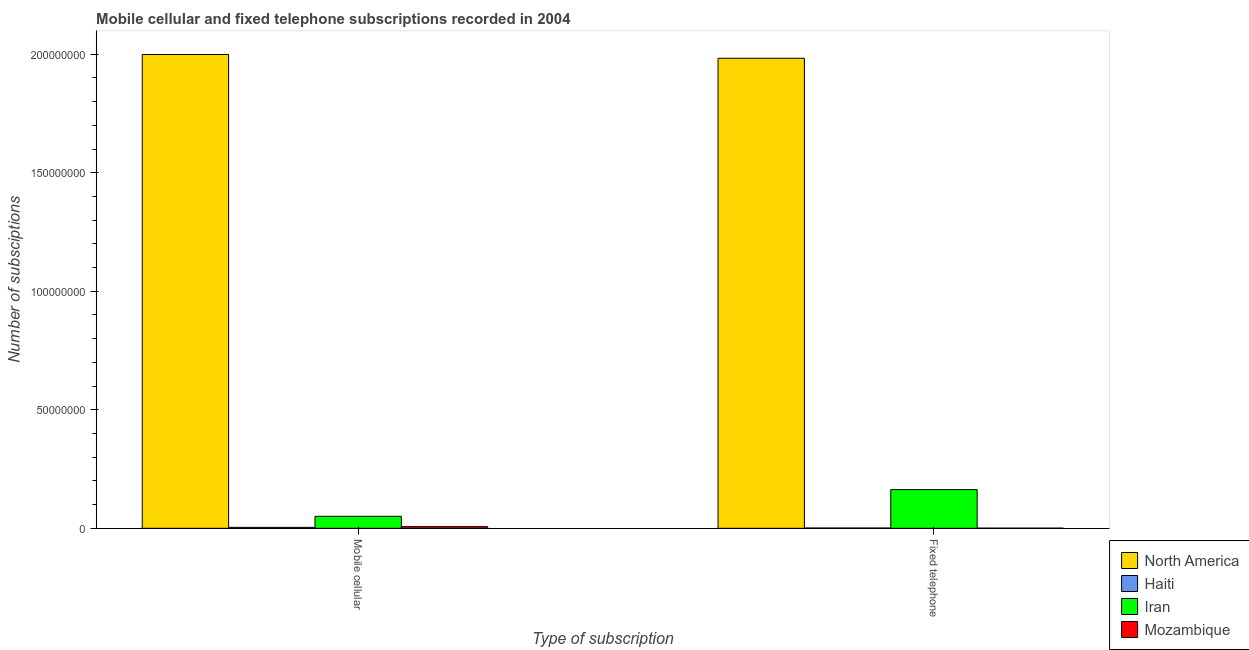Are the number of bars per tick equal to the number of legend labels?
Keep it short and to the point. Yes. Are the number of bars on each tick of the X-axis equal?
Your answer should be very brief. Yes. How many bars are there on the 2nd tick from the left?
Give a very brief answer. 4. How many bars are there on the 1st tick from the right?
Make the answer very short. 4. What is the label of the 2nd group of bars from the left?
Offer a very short reply. Fixed telephone. What is the number of mobile cellular subscriptions in North America?
Offer a terse response. 2.00e+08. Across all countries, what is the maximum number of fixed telephone subscriptions?
Your answer should be very brief. 1.98e+08. Across all countries, what is the minimum number of mobile cellular subscriptions?
Offer a terse response. 4.00e+05. In which country was the number of fixed telephone subscriptions maximum?
Provide a short and direct response. North America. In which country was the number of fixed telephone subscriptions minimum?
Offer a very short reply. Mozambique. What is the total number of fixed telephone subscriptions in the graph?
Ensure brevity in your answer.  2.15e+08. What is the difference between the number of mobile cellular subscriptions in Mozambique and that in Haiti?
Your answer should be very brief. 3.08e+05. What is the difference between the number of fixed telephone subscriptions in Iran and the number of mobile cellular subscriptions in Mozambique?
Give a very brief answer. 1.56e+07. What is the average number of fixed telephone subscriptions per country?
Provide a short and direct response. 5.37e+07. What is the difference between the number of fixed telephone subscriptions and number of mobile cellular subscriptions in North America?
Keep it short and to the point. -1.58e+06. In how many countries, is the number of fixed telephone subscriptions greater than 140000000 ?
Provide a succinct answer. 1. What is the ratio of the number of mobile cellular subscriptions in North America to that in Haiti?
Provide a succinct answer. 499.72. Is the number of mobile cellular subscriptions in North America less than that in Iran?
Offer a terse response. No. In how many countries, is the number of mobile cellular subscriptions greater than the average number of mobile cellular subscriptions taken over all countries?
Your response must be concise. 1. What does the 2nd bar from the left in Mobile cellular represents?
Provide a short and direct response. Haiti. What does the 1st bar from the right in Fixed telephone represents?
Your answer should be compact. Mozambique. Does the graph contain any zero values?
Provide a succinct answer. No. Where does the legend appear in the graph?
Your answer should be compact. Bottom right. What is the title of the graph?
Provide a short and direct response. Mobile cellular and fixed telephone subscriptions recorded in 2004. What is the label or title of the X-axis?
Your answer should be compact. Type of subscription. What is the label or title of the Y-axis?
Your answer should be very brief. Number of subsciptions. What is the Number of subsciptions in North America in Mobile cellular?
Give a very brief answer. 2.00e+08. What is the Number of subsciptions of Haiti in Mobile cellular?
Provide a short and direct response. 4.00e+05. What is the Number of subsciptions of Iran in Mobile cellular?
Keep it short and to the point. 5.08e+06. What is the Number of subsciptions of Mozambique in Mobile cellular?
Offer a terse response. 7.08e+05. What is the Number of subsciptions of North America in Fixed telephone?
Make the answer very short. 1.98e+08. What is the Number of subsciptions of Iran in Fixed telephone?
Your answer should be very brief. 1.63e+07. What is the Number of subsciptions in Mozambique in Fixed telephone?
Ensure brevity in your answer.  7.53e+04. Across all Type of subscription, what is the maximum Number of subsciptions in North America?
Provide a succinct answer. 2.00e+08. Across all Type of subscription, what is the maximum Number of subsciptions in Haiti?
Make the answer very short. 4.00e+05. Across all Type of subscription, what is the maximum Number of subsciptions in Iran?
Your answer should be very brief. 1.63e+07. Across all Type of subscription, what is the maximum Number of subsciptions in Mozambique?
Offer a terse response. 7.08e+05. Across all Type of subscription, what is the minimum Number of subsciptions of North America?
Your response must be concise. 1.98e+08. Across all Type of subscription, what is the minimum Number of subsciptions of Haiti?
Provide a short and direct response. 1.40e+05. Across all Type of subscription, what is the minimum Number of subsciptions in Iran?
Ensure brevity in your answer.  5.08e+06. Across all Type of subscription, what is the minimum Number of subsciptions in Mozambique?
Your answer should be very brief. 7.53e+04. What is the total Number of subsciptions of North America in the graph?
Give a very brief answer. 3.98e+08. What is the total Number of subsciptions of Haiti in the graph?
Provide a succinct answer. 5.40e+05. What is the total Number of subsciptions in Iran in the graph?
Offer a terse response. 2.14e+07. What is the total Number of subsciptions in Mozambique in the graph?
Ensure brevity in your answer.  7.83e+05. What is the difference between the Number of subsciptions of North America in Mobile cellular and that in Fixed telephone?
Provide a succinct answer. 1.58e+06. What is the difference between the Number of subsciptions in Haiti in Mobile cellular and that in Fixed telephone?
Provide a short and direct response. 2.60e+05. What is the difference between the Number of subsciptions in Iran in Mobile cellular and that in Fixed telephone?
Your answer should be compact. -1.13e+07. What is the difference between the Number of subsciptions in Mozambique in Mobile cellular and that in Fixed telephone?
Offer a very short reply. 6.33e+05. What is the difference between the Number of subsciptions in North America in Mobile cellular and the Number of subsciptions in Haiti in Fixed telephone?
Offer a very short reply. 2.00e+08. What is the difference between the Number of subsciptions in North America in Mobile cellular and the Number of subsciptions in Iran in Fixed telephone?
Your answer should be very brief. 1.84e+08. What is the difference between the Number of subsciptions in North America in Mobile cellular and the Number of subsciptions in Mozambique in Fixed telephone?
Make the answer very short. 2.00e+08. What is the difference between the Number of subsciptions in Haiti in Mobile cellular and the Number of subsciptions in Iran in Fixed telephone?
Ensure brevity in your answer.  -1.59e+07. What is the difference between the Number of subsciptions of Haiti in Mobile cellular and the Number of subsciptions of Mozambique in Fixed telephone?
Provide a short and direct response. 3.25e+05. What is the difference between the Number of subsciptions of Iran in Mobile cellular and the Number of subsciptions of Mozambique in Fixed telephone?
Offer a very short reply. 5.00e+06. What is the average Number of subsciptions of North America per Type of subscription?
Your answer should be very brief. 1.99e+08. What is the average Number of subsciptions in Iran per Type of subscription?
Keep it short and to the point. 1.07e+07. What is the average Number of subsciptions of Mozambique per Type of subscription?
Offer a terse response. 3.92e+05. What is the difference between the Number of subsciptions of North America and Number of subsciptions of Haiti in Mobile cellular?
Your response must be concise. 1.99e+08. What is the difference between the Number of subsciptions in North America and Number of subsciptions in Iran in Mobile cellular?
Provide a short and direct response. 1.95e+08. What is the difference between the Number of subsciptions of North America and Number of subsciptions of Mozambique in Mobile cellular?
Give a very brief answer. 1.99e+08. What is the difference between the Number of subsciptions in Haiti and Number of subsciptions in Iran in Mobile cellular?
Your response must be concise. -4.68e+06. What is the difference between the Number of subsciptions of Haiti and Number of subsciptions of Mozambique in Mobile cellular?
Keep it short and to the point. -3.08e+05. What is the difference between the Number of subsciptions in Iran and Number of subsciptions in Mozambique in Mobile cellular?
Offer a very short reply. 4.37e+06. What is the difference between the Number of subsciptions of North America and Number of subsciptions of Haiti in Fixed telephone?
Your answer should be compact. 1.98e+08. What is the difference between the Number of subsciptions in North America and Number of subsciptions in Iran in Fixed telephone?
Provide a succinct answer. 1.82e+08. What is the difference between the Number of subsciptions of North America and Number of subsciptions of Mozambique in Fixed telephone?
Keep it short and to the point. 1.98e+08. What is the difference between the Number of subsciptions of Haiti and Number of subsciptions of Iran in Fixed telephone?
Your answer should be compact. -1.62e+07. What is the difference between the Number of subsciptions of Haiti and Number of subsciptions of Mozambique in Fixed telephone?
Your response must be concise. 6.47e+04. What is the difference between the Number of subsciptions in Iran and Number of subsciptions in Mozambique in Fixed telephone?
Provide a short and direct response. 1.63e+07. What is the ratio of the Number of subsciptions in Haiti in Mobile cellular to that in Fixed telephone?
Offer a very short reply. 2.86. What is the ratio of the Number of subsciptions in Iran in Mobile cellular to that in Fixed telephone?
Give a very brief answer. 0.31. What is the ratio of the Number of subsciptions in Mozambique in Mobile cellular to that in Fixed telephone?
Provide a succinct answer. 9.41. What is the difference between the highest and the second highest Number of subsciptions in North America?
Give a very brief answer. 1.58e+06. What is the difference between the highest and the second highest Number of subsciptions in Haiti?
Offer a very short reply. 2.60e+05. What is the difference between the highest and the second highest Number of subsciptions of Iran?
Offer a very short reply. 1.13e+07. What is the difference between the highest and the second highest Number of subsciptions in Mozambique?
Offer a terse response. 6.33e+05. What is the difference between the highest and the lowest Number of subsciptions of North America?
Give a very brief answer. 1.58e+06. What is the difference between the highest and the lowest Number of subsciptions in Iran?
Your answer should be compact. 1.13e+07. What is the difference between the highest and the lowest Number of subsciptions in Mozambique?
Offer a very short reply. 6.33e+05. 